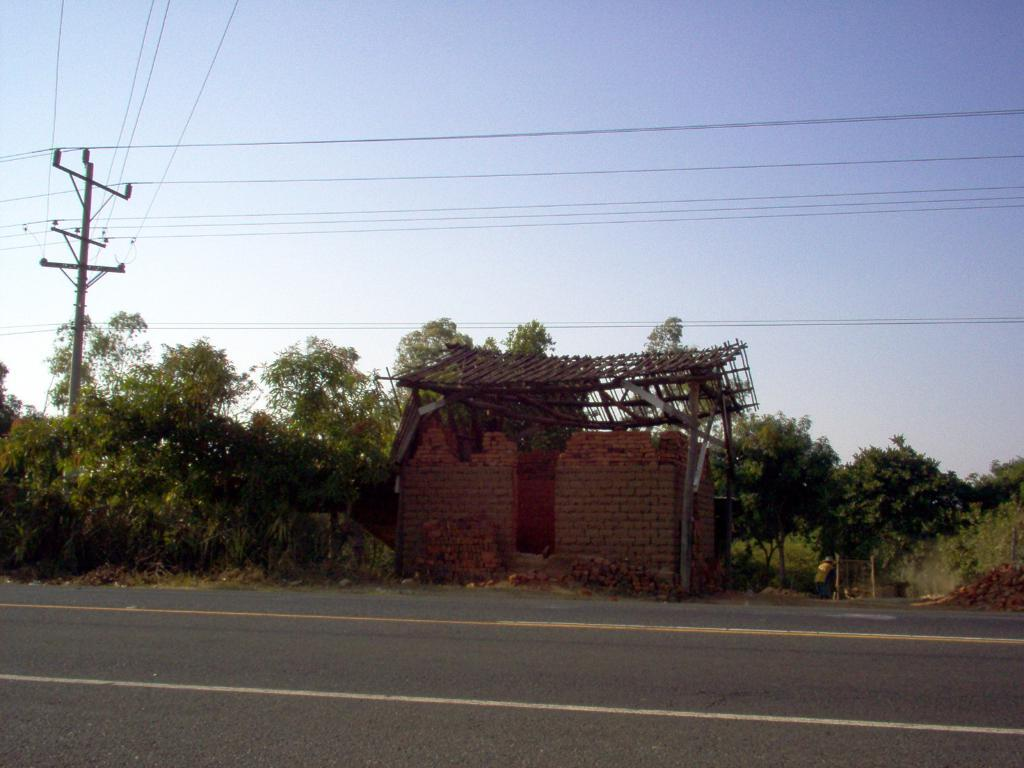What is located at the bottom of the image? There is a road at the bottom of the image. What type of structure can be seen in the image? There is a brick wall in the image. What type of vegetation is on the left side of the image? There are trees on the left side of the image. What is visible at the top of the image? The sky is visible at the top of the image. How many chickens are crossing the road in the image? There are no chickens present in the image. What type of news can be seen on the brick wall in the image? There is no news present on the brick wall in the image. 